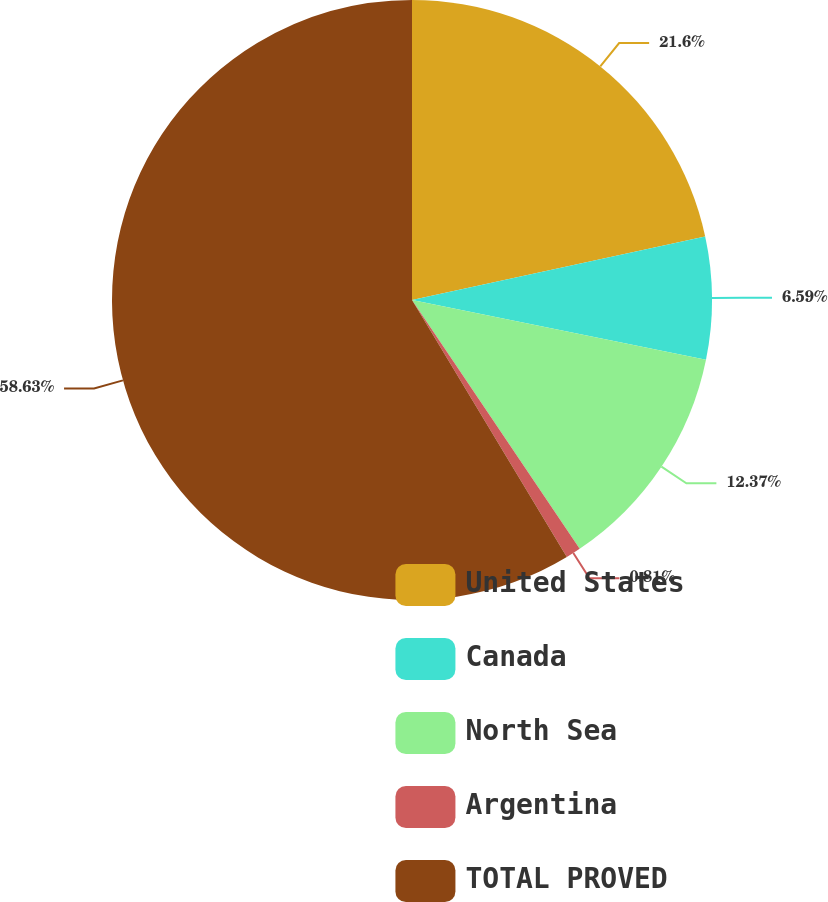Convert chart. <chart><loc_0><loc_0><loc_500><loc_500><pie_chart><fcel>United States<fcel>Canada<fcel>North Sea<fcel>Argentina<fcel>TOTAL PROVED<nl><fcel>21.6%<fcel>6.59%<fcel>12.37%<fcel>0.81%<fcel>58.63%<nl></chart> 